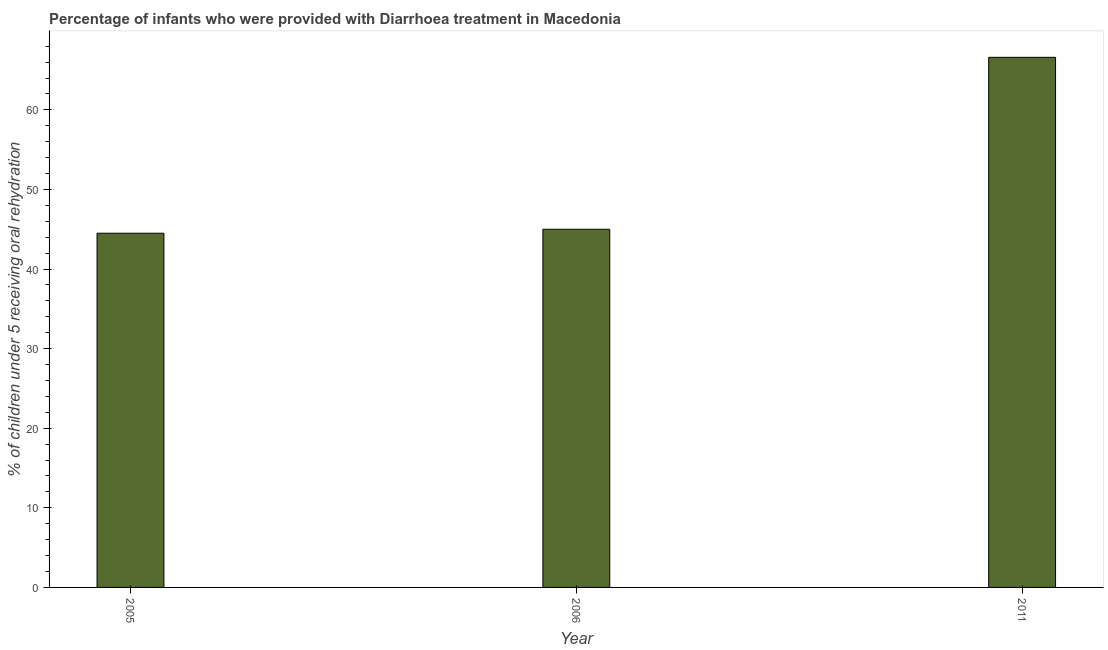Does the graph contain grids?
Give a very brief answer. No. What is the title of the graph?
Provide a succinct answer. Percentage of infants who were provided with Diarrhoea treatment in Macedonia. What is the label or title of the X-axis?
Your answer should be very brief. Year. What is the label or title of the Y-axis?
Make the answer very short. % of children under 5 receiving oral rehydration. What is the percentage of children who were provided with treatment diarrhoea in 2011?
Keep it short and to the point. 66.6. Across all years, what is the maximum percentage of children who were provided with treatment diarrhoea?
Your response must be concise. 66.6. Across all years, what is the minimum percentage of children who were provided with treatment diarrhoea?
Your answer should be compact. 44.5. In which year was the percentage of children who were provided with treatment diarrhoea maximum?
Give a very brief answer. 2011. In which year was the percentage of children who were provided with treatment diarrhoea minimum?
Keep it short and to the point. 2005. What is the sum of the percentage of children who were provided with treatment diarrhoea?
Make the answer very short. 156.1. What is the difference between the percentage of children who were provided with treatment diarrhoea in 2005 and 2006?
Offer a very short reply. -0.5. What is the average percentage of children who were provided with treatment diarrhoea per year?
Ensure brevity in your answer.  52.03. Do a majority of the years between 2011 and 2005 (inclusive) have percentage of children who were provided with treatment diarrhoea greater than 40 %?
Provide a short and direct response. Yes. What is the ratio of the percentage of children who were provided with treatment diarrhoea in 2005 to that in 2011?
Your response must be concise. 0.67. Is the difference between the percentage of children who were provided with treatment diarrhoea in 2005 and 2011 greater than the difference between any two years?
Provide a short and direct response. Yes. What is the difference between the highest and the second highest percentage of children who were provided with treatment diarrhoea?
Provide a succinct answer. 21.6. What is the difference between the highest and the lowest percentage of children who were provided with treatment diarrhoea?
Provide a short and direct response. 22.1. Are all the bars in the graph horizontal?
Offer a very short reply. No. How many years are there in the graph?
Give a very brief answer. 3. What is the difference between two consecutive major ticks on the Y-axis?
Offer a terse response. 10. Are the values on the major ticks of Y-axis written in scientific E-notation?
Keep it short and to the point. No. What is the % of children under 5 receiving oral rehydration in 2005?
Provide a short and direct response. 44.5. What is the % of children under 5 receiving oral rehydration in 2006?
Your answer should be very brief. 45. What is the % of children under 5 receiving oral rehydration of 2011?
Your response must be concise. 66.6. What is the difference between the % of children under 5 receiving oral rehydration in 2005 and 2006?
Offer a terse response. -0.5. What is the difference between the % of children under 5 receiving oral rehydration in 2005 and 2011?
Offer a very short reply. -22.1. What is the difference between the % of children under 5 receiving oral rehydration in 2006 and 2011?
Your answer should be very brief. -21.6. What is the ratio of the % of children under 5 receiving oral rehydration in 2005 to that in 2006?
Your answer should be very brief. 0.99. What is the ratio of the % of children under 5 receiving oral rehydration in 2005 to that in 2011?
Your answer should be compact. 0.67. What is the ratio of the % of children under 5 receiving oral rehydration in 2006 to that in 2011?
Offer a very short reply. 0.68. 